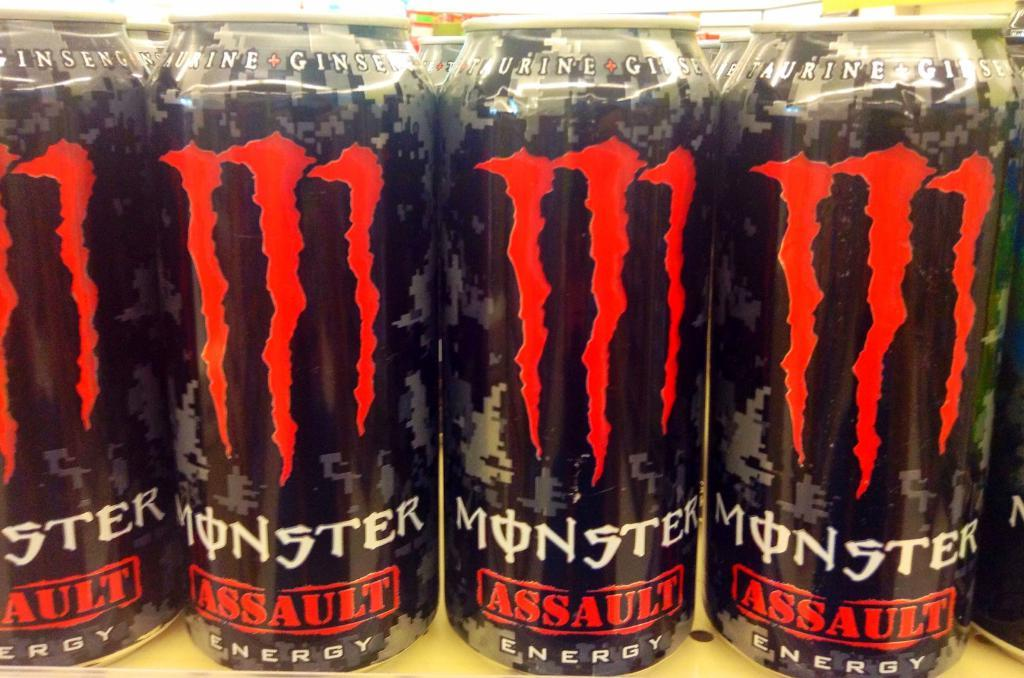<image>
Give a short and clear explanation of the subsequent image. The cans of Monster Assault energy drinks are lined up on a shelf. 